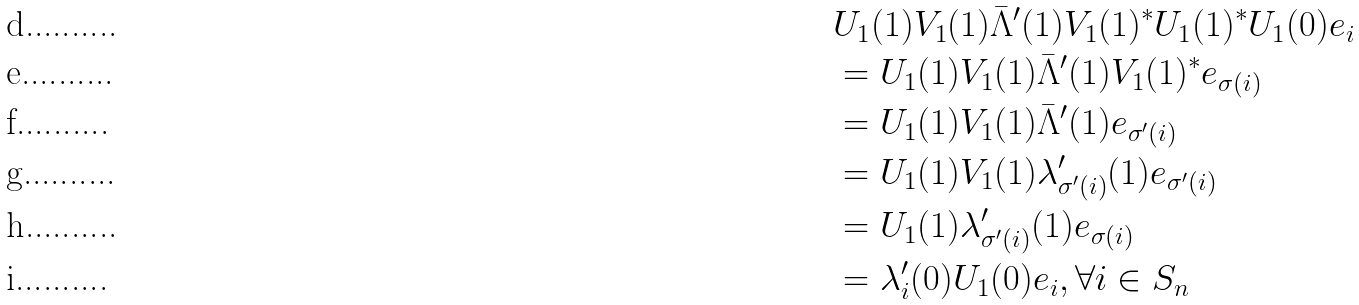<formula> <loc_0><loc_0><loc_500><loc_500>& U _ { 1 } ( 1 ) V _ { 1 } ( 1 ) \bar { \Lambda } ^ { \prime } ( 1 ) V _ { 1 } ( 1 ) ^ { * } U _ { 1 } ( 1 ) ^ { * } U _ { 1 } ( 0 ) e _ { i } \\ & = U _ { 1 } ( 1 ) V _ { 1 } ( 1 ) \bar { \Lambda } ^ { \prime } ( 1 ) V _ { 1 } ( 1 ) ^ { * } e _ { \sigma ( i ) } \\ & = U _ { 1 } ( 1 ) V _ { 1 } ( 1 ) \bar { \Lambda } ^ { \prime } ( 1 ) e _ { \sigma ^ { \prime } ( i ) } \\ & = U _ { 1 } ( 1 ) V _ { 1 } ( 1 ) \lambda ^ { \prime } _ { \sigma ^ { \prime } ( i ) } ( 1 ) e _ { \sigma ^ { \prime } ( i ) } \\ & = U _ { 1 } ( 1 ) \lambda ^ { \prime } _ { \sigma ^ { \prime } ( i ) } ( 1 ) e _ { \sigma ( i ) } \\ & = \lambda ^ { \prime } _ { i } ( 0 ) U _ { 1 } ( 0 ) e _ { i } , \forall i \in S _ { n }</formula> 